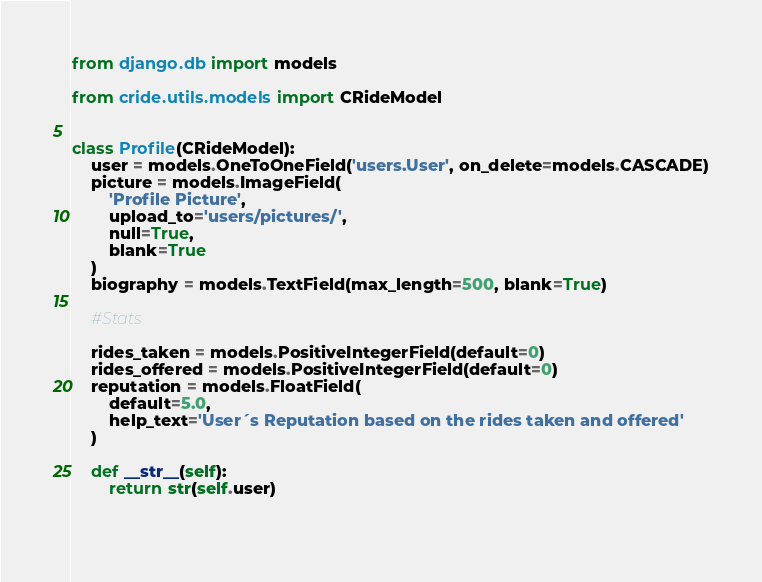<code> <loc_0><loc_0><loc_500><loc_500><_Python_>from django.db import models

from cride.utils.models import CRideModel


class Profile(CRideModel):
    user = models.OneToOneField('users.User', on_delete=models.CASCADE)
    picture = models.ImageField(
        'Profile Picture',
        upload_to='users/pictures/',
        null=True,
        blank=True
    )
    biography = models.TextField(max_length=500, blank=True)

    #Stats

    rides_taken = models.PositiveIntegerField(default=0)
    rides_offered = models.PositiveIntegerField(default=0)
    reputation = models.FloatField(
        default=5.0,
        help_text='User´s Reputation based on the rides taken and offered'
    )

    def __str__(self):
        return str(self.user)
    
    
</code> 